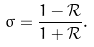Convert formula to latex. <formula><loc_0><loc_0><loc_500><loc_500>\sigma = \frac { 1 - \mathcal { R } } { 1 + \mathcal { R } } .</formula> 